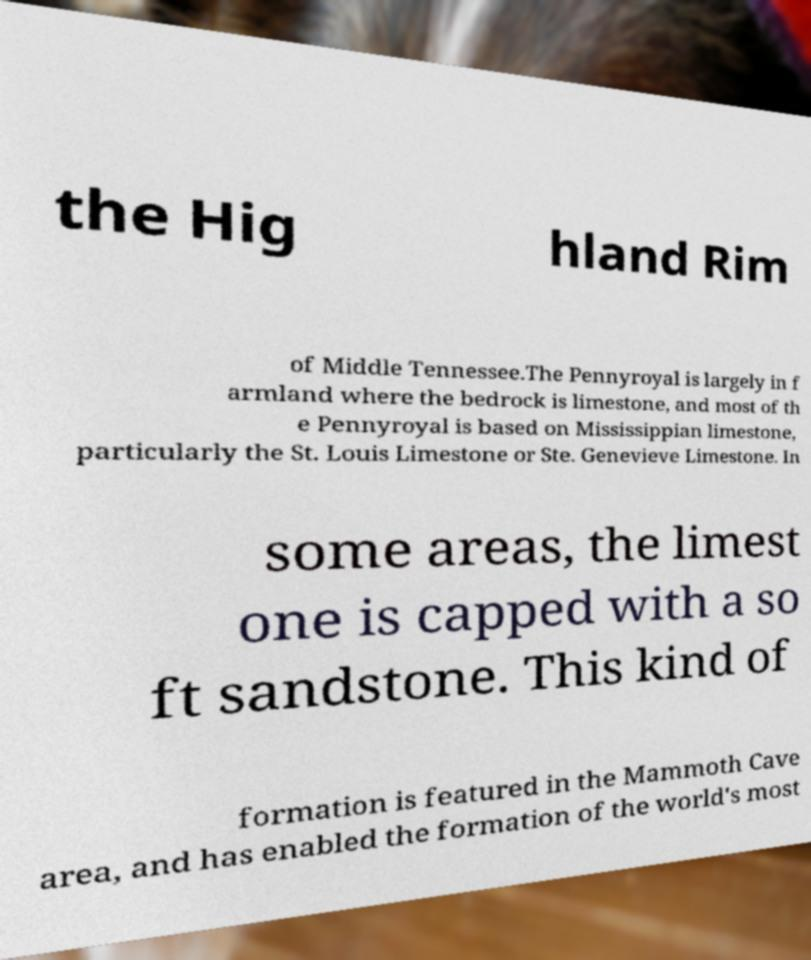Can you read and provide the text displayed in the image?This photo seems to have some interesting text. Can you extract and type it out for me? the Hig hland Rim of Middle Tennessee.The Pennyroyal is largely in f armland where the bedrock is limestone, and most of th e Pennyroyal is based on Mississippian limestone, particularly the St. Louis Limestone or Ste. Genevieve Limestone. In some areas, the limest one is capped with a so ft sandstone. This kind of formation is featured in the Mammoth Cave area, and has enabled the formation of the world's most 